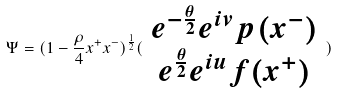Convert formula to latex. <formula><loc_0><loc_0><loc_500><loc_500>\Psi = ( 1 - \frac { \rho } { 4 } x ^ { + } x ^ { - } ) ^ { \frac { 1 } { 2 } } ( \begin{array} { c } e ^ { - \frac { \theta } { 2 } } e ^ { i v } p ( x ^ { - } ) \\ e ^ { \frac { \theta } { 2 } } e ^ { i u } f ( x ^ { + } ) \end{array} )</formula> 